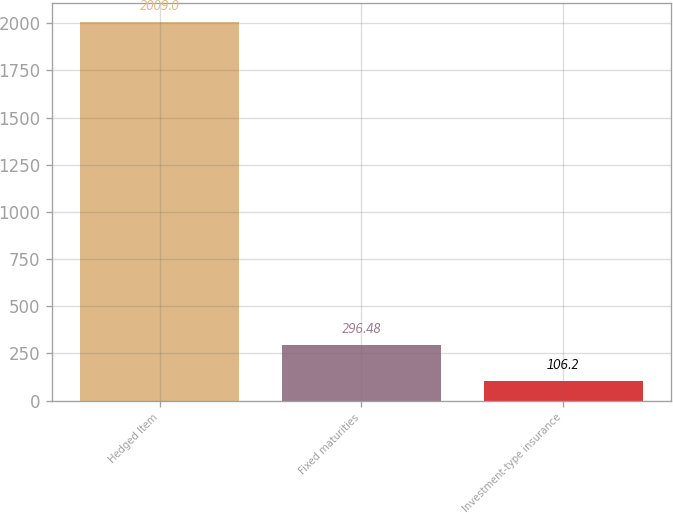Convert chart to OTSL. <chart><loc_0><loc_0><loc_500><loc_500><bar_chart><fcel>Hedged Item<fcel>Fixed maturities<fcel>Investment-type insurance<nl><fcel>2009<fcel>296.48<fcel>106.2<nl></chart> 